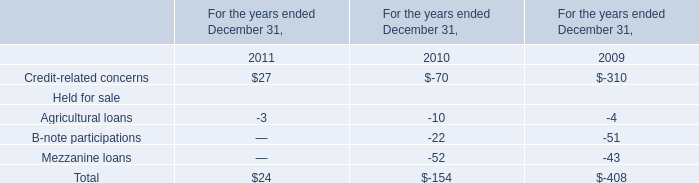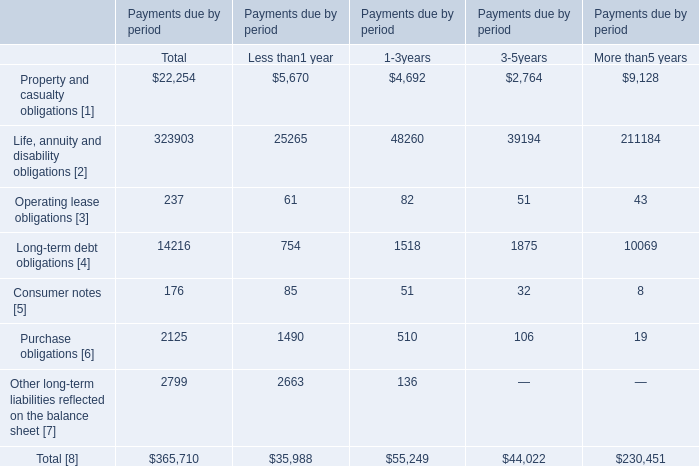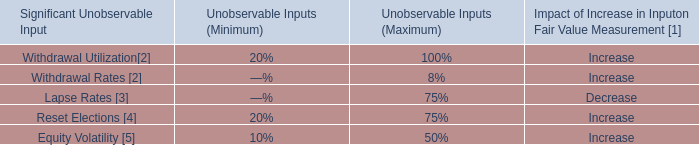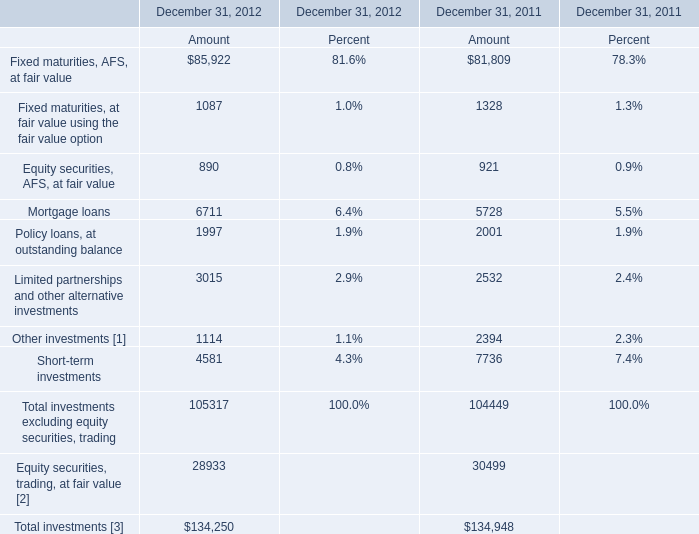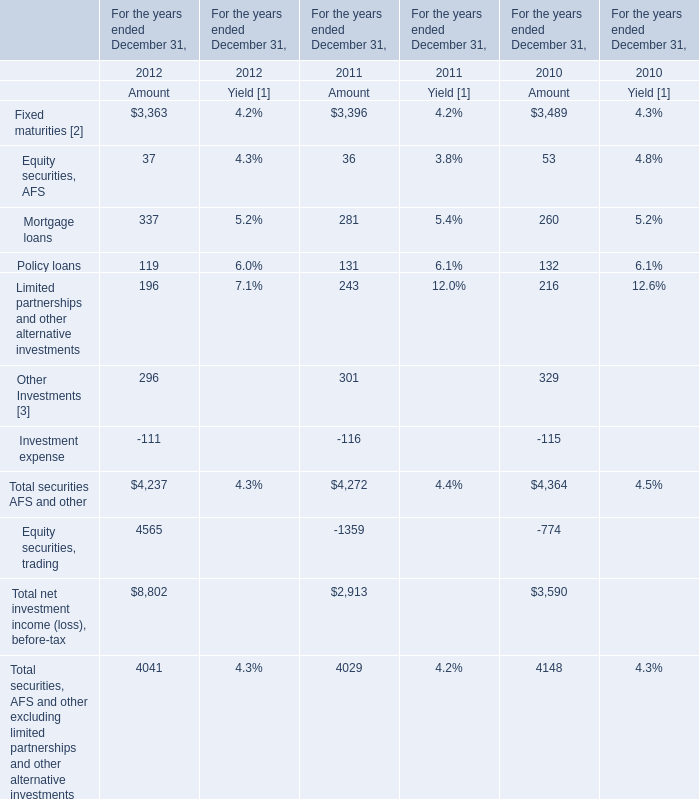Which year is Amount of Total investments excluding equity securities, trading higher? 
Answer: 2012. 